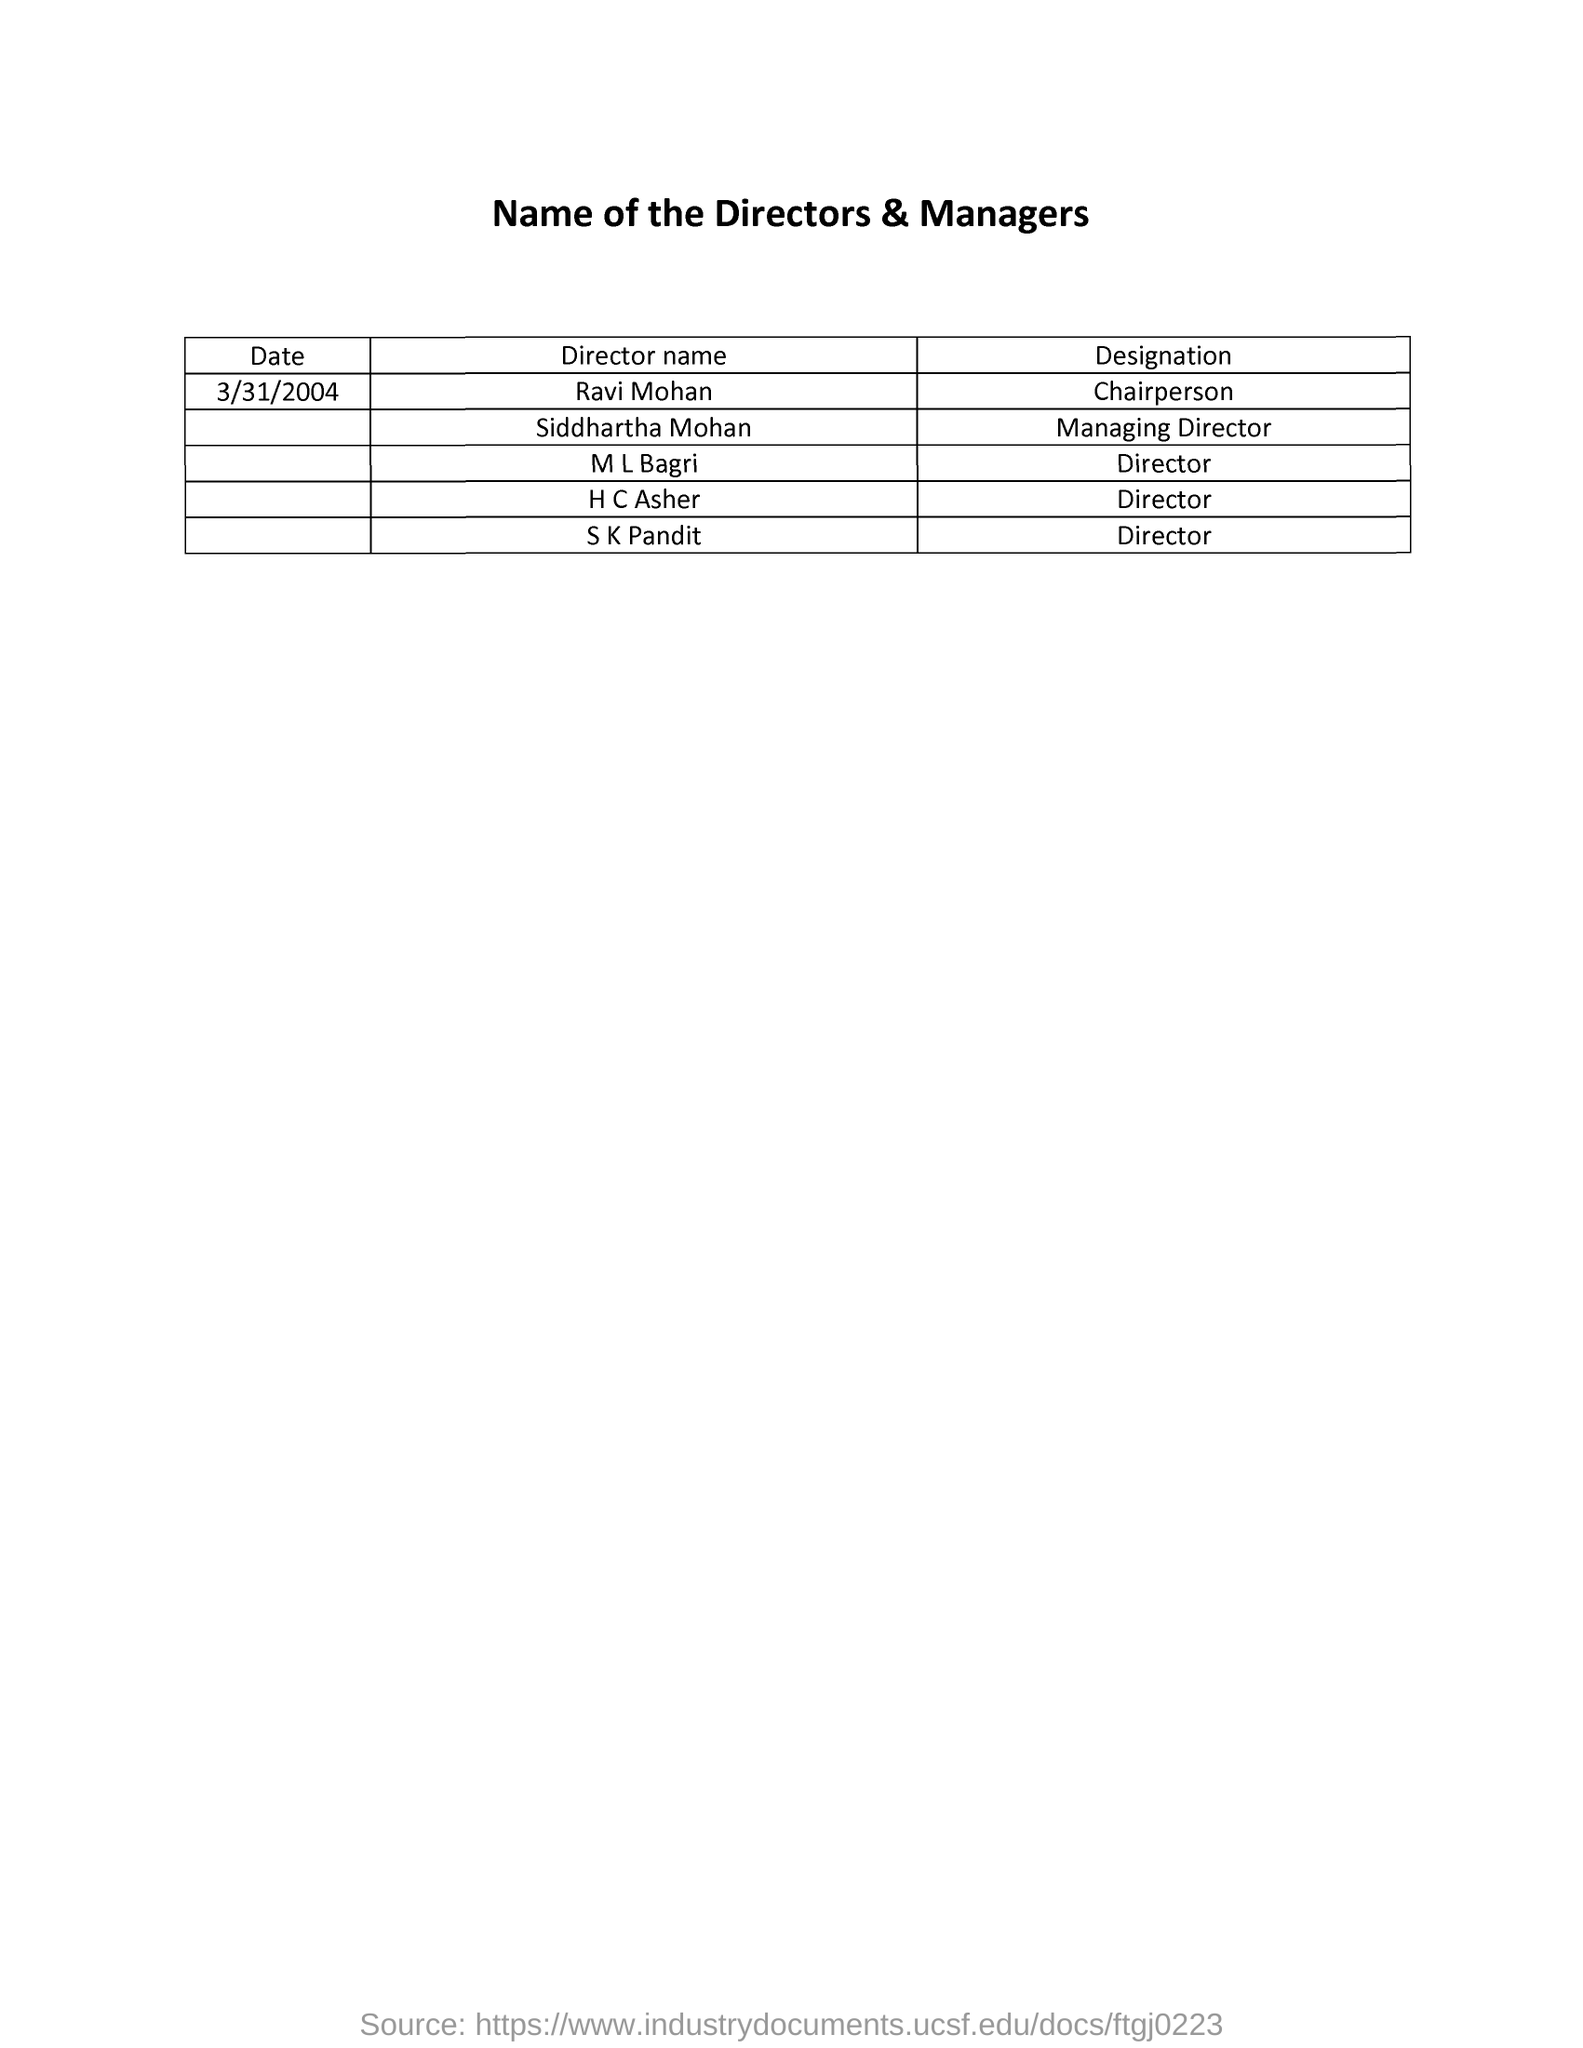What is the Title of the document ?
Your answer should be very brief. Name of the directors & managers. What is the date mentioned in the document ?
Provide a succinct answer. 3/31/2004. What is the Designation of Ravi Mohan ?
Offer a very short reply. Chairperson. 